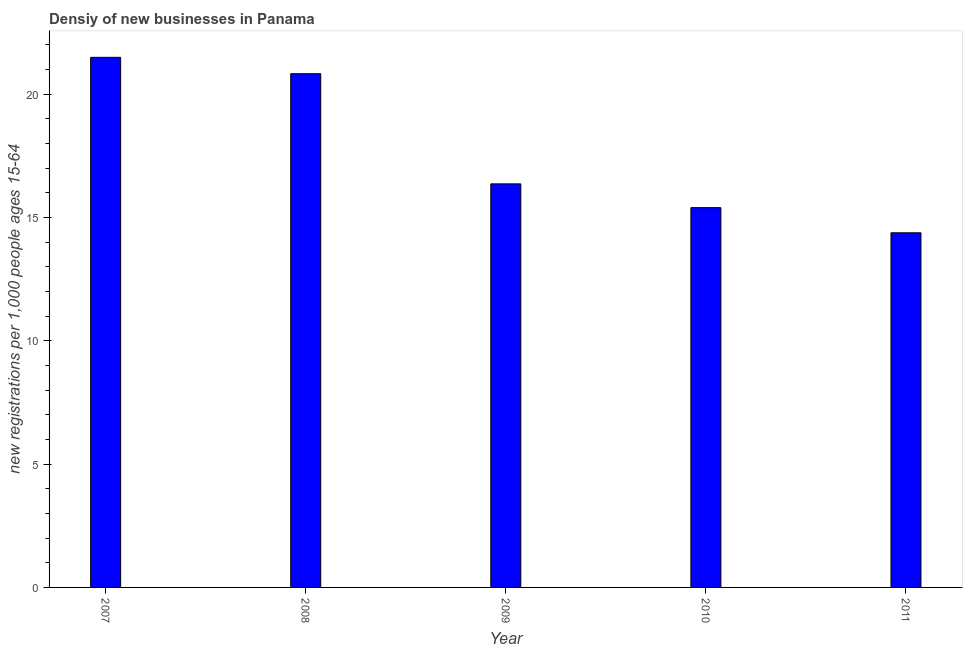What is the title of the graph?
Your answer should be compact. Densiy of new businesses in Panama. What is the label or title of the Y-axis?
Your response must be concise. New registrations per 1,0 people ages 15-64. What is the density of new business in 2008?
Keep it short and to the point. 20.82. Across all years, what is the maximum density of new business?
Your response must be concise. 21.49. Across all years, what is the minimum density of new business?
Your response must be concise. 14.38. What is the sum of the density of new business?
Your answer should be very brief. 88.44. What is the difference between the density of new business in 2009 and 2010?
Offer a very short reply. 0.96. What is the average density of new business per year?
Provide a short and direct response. 17.69. What is the median density of new business?
Your response must be concise. 16.36. In how many years, is the density of new business greater than 8 ?
Give a very brief answer. 5. What is the ratio of the density of new business in 2007 to that in 2009?
Your response must be concise. 1.31. What is the difference between the highest and the second highest density of new business?
Provide a short and direct response. 0.66. What is the difference between the highest and the lowest density of new business?
Give a very brief answer. 7.11. In how many years, is the density of new business greater than the average density of new business taken over all years?
Ensure brevity in your answer.  2. How many years are there in the graph?
Provide a short and direct response. 5. What is the new registrations per 1,000 people ages 15-64 in 2007?
Make the answer very short. 21.49. What is the new registrations per 1,000 people ages 15-64 of 2008?
Your answer should be compact. 20.82. What is the new registrations per 1,000 people ages 15-64 in 2009?
Offer a terse response. 16.36. What is the new registrations per 1,000 people ages 15-64 of 2010?
Keep it short and to the point. 15.39. What is the new registrations per 1,000 people ages 15-64 in 2011?
Your answer should be compact. 14.38. What is the difference between the new registrations per 1,000 people ages 15-64 in 2007 and 2008?
Offer a terse response. 0.66. What is the difference between the new registrations per 1,000 people ages 15-64 in 2007 and 2009?
Your answer should be very brief. 5.13. What is the difference between the new registrations per 1,000 people ages 15-64 in 2007 and 2010?
Ensure brevity in your answer.  6.09. What is the difference between the new registrations per 1,000 people ages 15-64 in 2007 and 2011?
Offer a terse response. 7.11. What is the difference between the new registrations per 1,000 people ages 15-64 in 2008 and 2009?
Ensure brevity in your answer.  4.47. What is the difference between the new registrations per 1,000 people ages 15-64 in 2008 and 2010?
Offer a terse response. 5.43. What is the difference between the new registrations per 1,000 people ages 15-64 in 2008 and 2011?
Keep it short and to the point. 6.45. What is the difference between the new registrations per 1,000 people ages 15-64 in 2009 and 2010?
Your response must be concise. 0.96. What is the difference between the new registrations per 1,000 people ages 15-64 in 2009 and 2011?
Make the answer very short. 1.98. What is the difference between the new registrations per 1,000 people ages 15-64 in 2010 and 2011?
Provide a short and direct response. 1.02. What is the ratio of the new registrations per 1,000 people ages 15-64 in 2007 to that in 2008?
Provide a succinct answer. 1.03. What is the ratio of the new registrations per 1,000 people ages 15-64 in 2007 to that in 2009?
Your response must be concise. 1.31. What is the ratio of the new registrations per 1,000 people ages 15-64 in 2007 to that in 2010?
Offer a terse response. 1.4. What is the ratio of the new registrations per 1,000 people ages 15-64 in 2007 to that in 2011?
Provide a succinct answer. 1.5. What is the ratio of the new registrations per 1,000 people ages 15-64 in 2008 to that in 2009?
Provide a short and direct response. 1.27. What is the ratio of the new registrations per 1,000 people ages 15-64 in 2008 to that in 2010?
Your response must be concise. 1.35. What is the ratio of the new registrations per 1,000 people ages 15-64 in 2008 to that in 2011?
Provide a succinct answer. 1.45. What is the ratio of the new registrations per 1,000 people ages 15-64 in 2009 to that in 2010?
Keep it short and to the point. 1.06. What is the ratio of the new registrations per 1,000 people ages 15-64 in 2009 to that in 2011?
Offer a terse response. 1.14. What is the ratio of the new registrations per 1,000 people ages 15-64 in 2010 to that in 2011?
Ensure brevity in your answer.  1.07. 